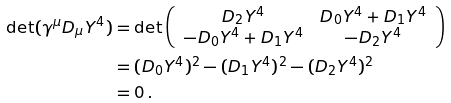<formula> <loc_0><loc_0><loc_500><loc_500>\det ( \gamma ^ { \mu } D _ { \mu } Y ^ { 4 } ) & = \det \left ( \begin{array} { c c } D _ { 2 } Y ^ { 4 } & D _ { 0 } Y ^ { 4 } + D _ { 1 } Y ^ { 4 } \\ - D _ { 0 } Y ^ { 4 } + D _ { 1 } Y ^ { 4 } & - D _ { 2 } Y ^ { 4 } \end{array} \right ) \\ & = ( D _ { 0 } Y ^ { 4 } ) ^ { 2 } - ( D _ { 1 } Y ^ { 4 } ) ^ { 2 } - ( D _ { 2 } Y ^ { 4 } ) ^ { 2 } \\ & = 0 \, .</formula> 